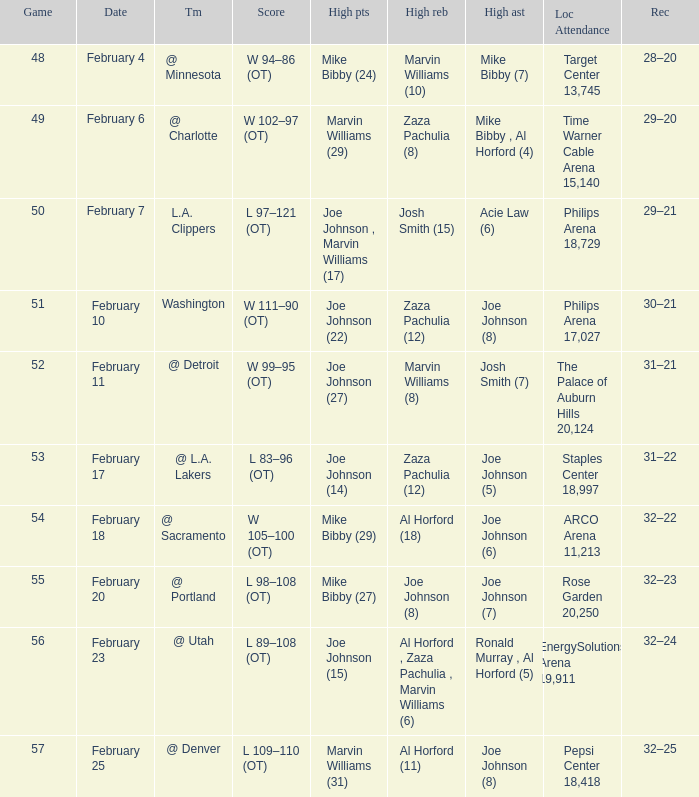Who made high assists on february 4 Mike Bibby (7). 